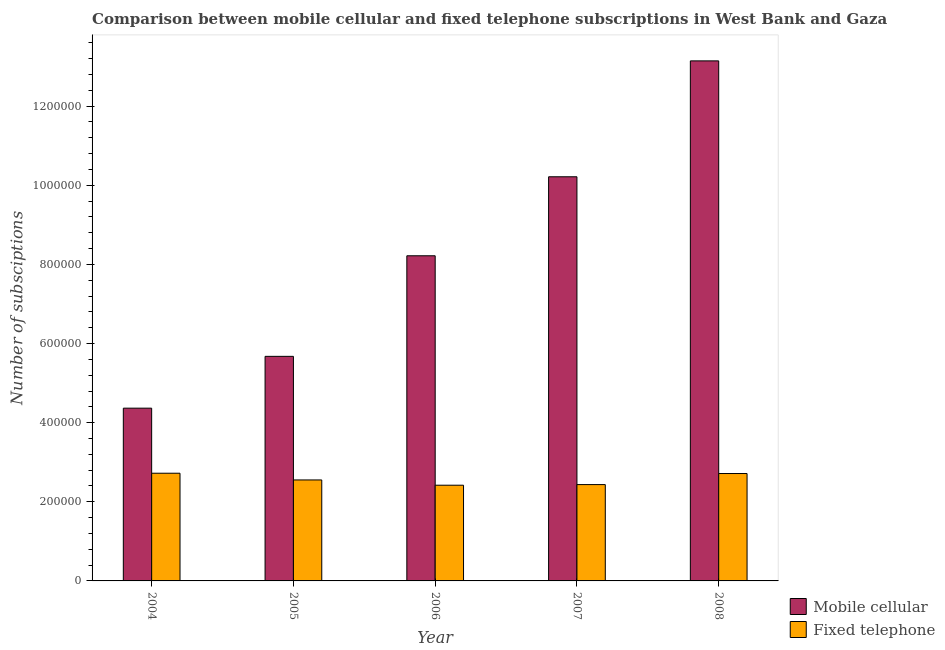How many groups of bars are there?
Provide a short and direct response. 5. Are the number of bars per tick equal to the number of legend labels?
Make the answer very short. Yes. Are the number of bars on each tick of the X-axis equal?
Make the answer very short. Yes. What is the label of the 5th group of bars from the left?
Make the answer very short. 2008. In how many cases, is the number of bars for a given year not equal to the number of legend labels?
Provide a succinct answer. 0. What is the number of fixed telephone subscriptions in 2007?
Provide a succinct answer. 2.43e+05. Across all years, what is the maximum number of fixed telephone subscriptions?
Give a very brief answer. 2.72e+05. Across all years, what is the minimum number of mobile cellular subscriptions?
Provide a short and direct response. 4.37e+05. In which year was the number of mobile cellular subscriptions minimum?
Keep it short and to the point. 2004. What is the total number of fixed telephone subscriptions in the graph?
Your response must be concise. 1.28e+06. What is the difference between the number of fixed telephone subscriptions in 2004 and that in 2005?
Your response must be concise. 1.70e+04. What is the difference between the number of fixed telephone subscriptions in 2006 and the number of mobile cellular subscriptions in 2007?
Provide a succinct answer. -1600. What is the average number of mobile cellular subscriptions per year?
Your response must be concise. 8.32e+05. In how many years, is the number of fixed telephone subscriptions greater than 840000?
Keep it short and to the point. 0. What is the ratio of the number of fixed telephone subscriptions in 2007 to that in 2008?
Your answer should be compact. 0.9. What is the difference between the highest and the second highest number of mobile cellular subscriptions?
Your response must be concise. 2.93e+05. What is the difference between the highest and the lowest number of mobile cellular subscriptions?
Make the answer very short. 8.78e+05. In how many years, is the number of mobile cellular subscriptions greater than the average number of mobile cellular subscriptions taken over all years?
Your answer should be compact. 2. What does the 1st bar from the left in 2004 represents?
Ensure brevity in your answer.  Mobile cellular. What does the 1st bar from the right in 2006 represents?
Provide a succinct answer. Fixed telephone. How many bars are there?
Make the answer very short. 10. What is the difference between two consecutive major ticks on the Y-axis?
Keep it short and to the point. 2.00e+05. Are the values on the major ticks of Y-axis written in scientific E-notation?
Provide a short and direct response. No. Does the graph contain grids?
Your response must be concise. No. Where does the legend appear in the graph?
Provide a short and direct response. Bottom right. How many legend labels are there?
Give a very brief answer. 2. How are the legend labels stacked?
Provide a short and direct response. Vertical. What is the title of the graph?
Make the answer very short. Comparison between mobile cellular and fixed telephone subscriptions in West Bank and Gaza. What is the label or title of the X-axis?
Offer a very short reply. Year. What is the label or title of the Y-axis?
Provide a succinct answer. Number of subsciptions. What is the Number of subsciptions in Mobile cellular in 2004?
Provide a short and direct response. 4.37e+05. What is the Number of subsciptions of Fixed telephone in 2004?
Provide a succinct answer. 2.72e+05. What is the Number of subsciptions of Mobile cellular in 2005?
Your answer should be compact. 5.68e+05. What is the Number of subsciptions of Fixed telephone in 2005?
Give a very brief answer. 2.55e+05. What is the Number of subsciptions in Mobile cellular in 2006?
Your response must be concise. 8.22e+05. What is the Number of subsciptions of Fixed telephone in 2006?
Provide a succinct answer. 2.42e+05. What is the Number of subsciptions of Mobile cellular in 2007?
Provide a succinct answer. 1.02e+06. What is the Number of subsciptions in Fixed telephone in 2007?
Ensure brevity in your answer.  2.43e+05. What is the Number of subsciptions in Mobile cellular in 2008?
Provide a short and direct response. 1.31e+06. What is the Number of subsciptions of Fixed telephone in 2008?
Your answer should be compact. 2.71e+05. Across all years, what is the maximum Number of subsciptions of Mobile cellular?
Your answer should be very brief. 1.31e+06. Across all years, what is the maximum Number of subsciptions in Fixed telephone?
Your answer should be compact. 2.72e+05. Across all years, what is the minimum Number of subsciptions of Mobile cellular?
Your answer should be compact. 4.37e+05. Across all years, what is the minimum Number of subsciptions in Fixed telephone?
Provide a succinct answer. 2.42e+05. What is the total Number of subsciptions of Mobile cellular in the graph?
Keep it short and to the point. 4.16e+06. What is the total Number of subsciptions in Fixed telephone in the graph?
Your response must be concise. 1.28e+06. What is the difference between the Number of subsciptions in Mobile cellular in 2004 and that in 2005?
Your response must be concise. -1.31e+05. What is the difference between the Number of subsciptions of Fixed telephone in 2004 and that in 2005?
Provide a short and direct response. 1.70e+04. What is the difference between the Number of subsciptions in Mobile cellular in 2004 and that in 2006?
Offer a terse response. -3.85e+05. What is the difference between the Number of subsciptions of Fixed telephone in 2004 and that in 2006?
Provide a succinct answer. 3.03e+04. What is the difference between the Number of subsciptions of Mobile cellular in 2004 and that in 2007?
Offer a terse response. -5.85e+05. What is the difference between the Number of subsciptions of Fixed telephone in 2004 and that in 2007?
Keep it short and to the point. 2.87e+04. What is the difference between the Number of subsciptions of Mobile cellular in 2004 and that in 2008?
Your answer should be very brief. -8.78e+05. What is the difference between the Number of subsciptions in Fixed telephone in 2004 and that in 2008?
Your answer should be compact. 753. What is the difference between the Number of subsciptions of Mobile cellular in 2005 and that in 2006?
Your response must be concise. -2.54e+05. What is the difference between the Number of subsciptions of Fixed telephone in 2005 and that in 2006?
Offer a terse response. 1.33e+04. What is the difference between the Number of subsciptions in Mobile cellular in 2005 and that in 2007?
Provide a succinct answer. -4.54e+05. What is the difference between the Number of subsciptions of Fixed telephone in 2005 and that in 2007?
Ensure brevity in your answer.  1.17e+04. What is the difference between the Number of subsciptions in Mobile cellular in 2005 and that in 2008?
Make the answer very short. -7.47e+05. What is the difference between the Number of subsciptions in Fixed telephone in 2005 and that in 2008?
Keep it short and to the point. -1.62e+04. What is the difference between the Number of subsciptions of Mobile cellular in 2006 and that in 2007?
Your response must be concise. -2.00e+05. What is the difference between the Number of subsciptions of Fixed telephone in 2006 and that in 2007?
Ensure brevity in your answer.  -1600. What is the difference between the Number of subsciptions of Mobile cellular in 2006 and that in 2008?
Your response must be concise. -4.93e+05. What is the difference between the Number of subsciptions in Fixed telephone in 2006 and that in 2008?
Offer a very short reply. -2.96e+04. What is the difference between the Number of subsciptions of Mobile cellular in 2007 and that in 2008?
Make the answer very short. -2.93e+05. What is the difference between the Number of subsciptions of Fixed telephone in 2007 and that in 2008?
Offer a very short reply. -2.80e+04. What is the difference between the Number of subsciptions in Mobile cellular in 2004 and the Number of subsciptions in Fixed telephone in 2005?
Your answer should be compact. 1.81e+05. What is the difference between the Number of subsciptions of Mobile cellular in 2004 and the Number of subsciptions of Fixed telephone in 2006?
Offer a very short reply. 1.95e+05. What is the difference between the Number of subsciptions of Mobile cellular in 2004 and the Number of subsciptions of Fixed telephone in 2007?
Give a very brief answer. 1.93e+05. What is the difference between the Number of subsciptions of Mobile cellular in 2004 and the Number of subsciptions of Fixed telephone in 2008?
Keep it short and to the point. 1.65e+05. What is the difference between the Number of subsciptions in Mobile cellular in 2005 and the Number of subsciptions in Fixed telephone in 2006?
Your answer should be very brief. 3.26e+05. What is the difference between the Number of subsciptions in Mobile cellular in 2005 and the Number of subsciptions in Fixed telephone in 2007?
Give a very brief answer. 3.24e+05. What is the difference between the Number of subsciptions of Mobile cellular in 2005 and the Number of subsciptions of Fixed telephone in 2008?
Provide a succinct answer. 2.96e+05. What is the difference between the Number of subsciptions in Mobile cellular in 2006 and the Number of subsciptions in Fixed telephone in 2007?
Make the answer very short. 5.78e+05. What is the difference between the Number of subsciptions of Mobile cellular in 2006 and the Number of subsciptions of Fixed telephone in 2008?
Make the answer very short. 5.50e+05. What is the difference between the Number of subsciptions of Mobile cellular in 2007 and the Number of subsciptions of Fixed telephone in 2008?
Ensure brevity in your answer.  7.50e+05. What is the average Number of subsciptions in Mobile cellular per year?
Provide a succinct answer. 8.32e+05. What is the average Number of subsciptions in Fixed telephone per year?
Your response must be concise. 2.57e+05. In the year 2004, what is the difference between the Number of subsciptions in Mobile cellular and Number of subsciptions in Fixed telephone?
Keep it short and to the point. 1.64e+05. In the year 2005, what is the difference between the Number of subsciptions of Mobile cellular and Number of subsciptions of Fixed telephone?
Ensure brevity in your answer.  3.12e+05. In the year 2006, what is the difference between the Number of subsciptions of Mobile cellular and Number of subsciptions of Fixed telephone?
Provide a short and direct response. 5.80e+05. In the year 2007, what is the difference between the Number of subsciptions in Mobile cellular and Number of subsciptions in Fixed telephone?
Provide a short and direct response. 7.78e+05. In the year 2008, what is the difference between the Number of subsciptions of Mobile cellular and Number of subsciptions of Fixed telephone?
Your answer should be compact. 1.04e+06. What is the ratio of the Number of subsciptions of Mobile cellular in 2004 to that in 2005?
Give a very brief answer. 0.77. What is the ratio of the Number of subsciptions in Fixed telephone in 2004 to that in 2005?
Provide a succinct answer. 1.07. What is the ratio of the Number of subsciptions in Mobile cellular in 2004 to that in 2006?
Provide a succinct answer. 0.53. What is the ratio of the Number of subsciptions of Fixed telephone in 2004 to that in 2006?
Ensure brevity in your answer.  1.13. What is the ratio of the Number of subsciptions of Mobile cellular in 2004 to that in 2007?
Give a very brief answer. 0.43. What is the ratio of the Number of subsciptions of Fixed telephone in 2004 to that in 2007?
Provide a short and direct response. 1.12. What is the ratio of the Number of subsciptions in Mobile cellular in 2004 to that in 2008?
Give a very brief answer. 0.33. What is the ratio of the Number of subsciptions in Fixed telephone in 2004 to that in 2008?
Ensure brevity in your answer.  1. What is the ratio of the Number of subsciptions in Mobile cellular in 2005 to that in 2006?
Offer a terse response. 0.69. What is the ratio of the Number of subsciptions in Fixed telephone in 2005 to that in 2006?
Make the answer very short. 1.06. What is the ratio of the Number of subsciptions in Mobile cellular in 2005 to that in 2007?
Offer a very short reply. 0.56. What is the ratio of the Number of subsciptions of Fixed telephone in 2005 to that in 2007?
Make the answer very short. 1.05. What is the ratio of the Number of subsciptions in Mobile cellular in 2005 to that in 2008?
Keep it short and to the point. 0.43. What is the ratio of the Number of subsciptions of Fixed telephone in 2005 to that in 2008?
Make the answer very short. 0.94. What is the ratio of the Number of subsciptions of Mobile cellular in 2006 to that in 2007?
Your answer should be very brief. 0.8. What is the ratio of the Number of subsciptions of Fixed telephone in 2006 to that in 2007?
Give a very brief answer. 0.99. What is the ratio of the Number of subsciptions in Mobile cellular in 2006 to that in 2008?
Give a very brief answer. 0.63. What is the ratio of the Number of subsciptions of Fixed telephone in 2006 to that in 2008?
Keep it short and to the point. 0.89. What is the ratio of the Number of subsciptions of Mobile cellular in 2007 to that in 2008?
Provide a succinct answer. 0.78. What is the ratio of the Number of subsciptions in Fixed telephone in 2007 to that in 2008?
Give a very brief answer. 0.9. What is the difference between the highest and the second highest Number of subsciptions in Mobile cellular?
Provide a short and direct response. 2.93e+05. What is the difference between the highest and the second highest Number of subsciptions in Fixed telephone?
Ensure brevity in your answer.  753. What is the difference between the highest and the lowest Number of subsciptions in Mobile cellular?
Keep it short and to the point. 8.78e+05. What is the difference between the highest and the lowest Number of subsciptions in Fixed telephone?
Your response must be concise. 3.03e+04. 